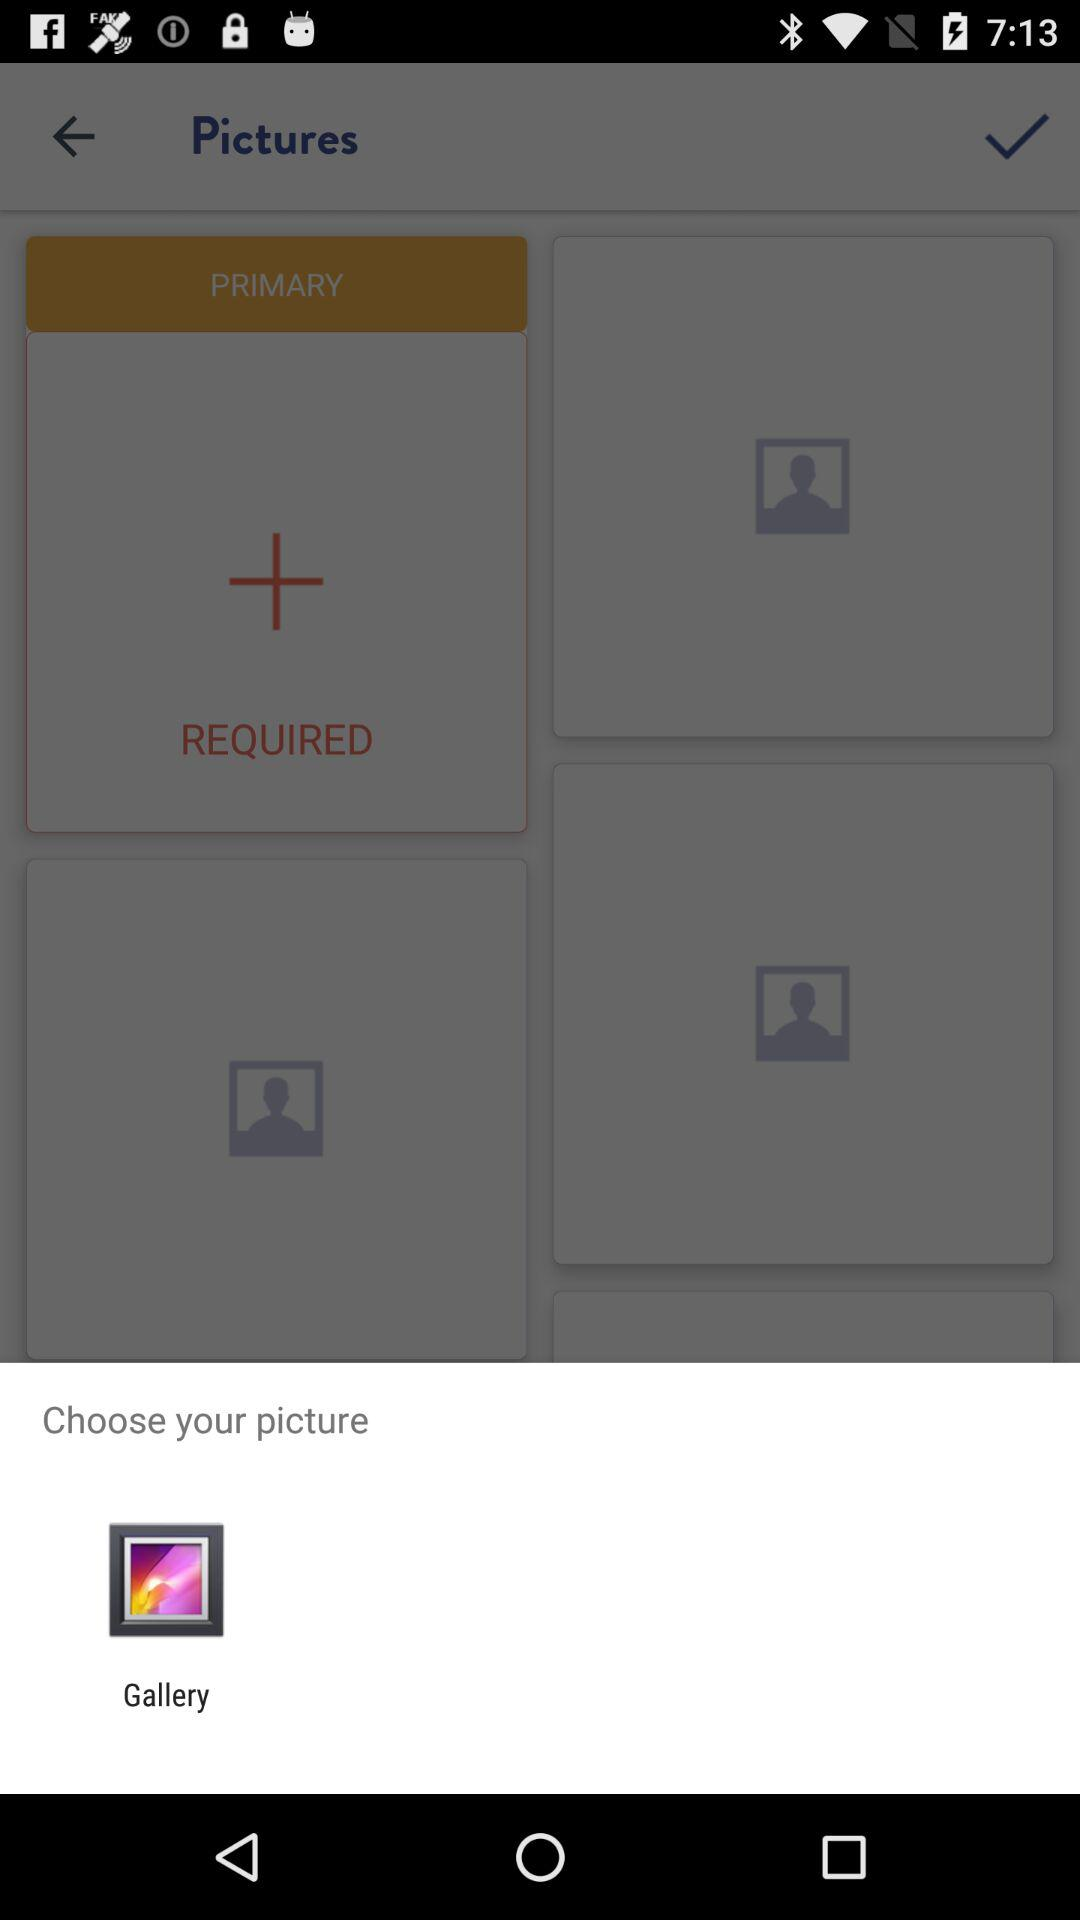What app can we use to open a picture? You can use the "Gallery" app to open a picture. 